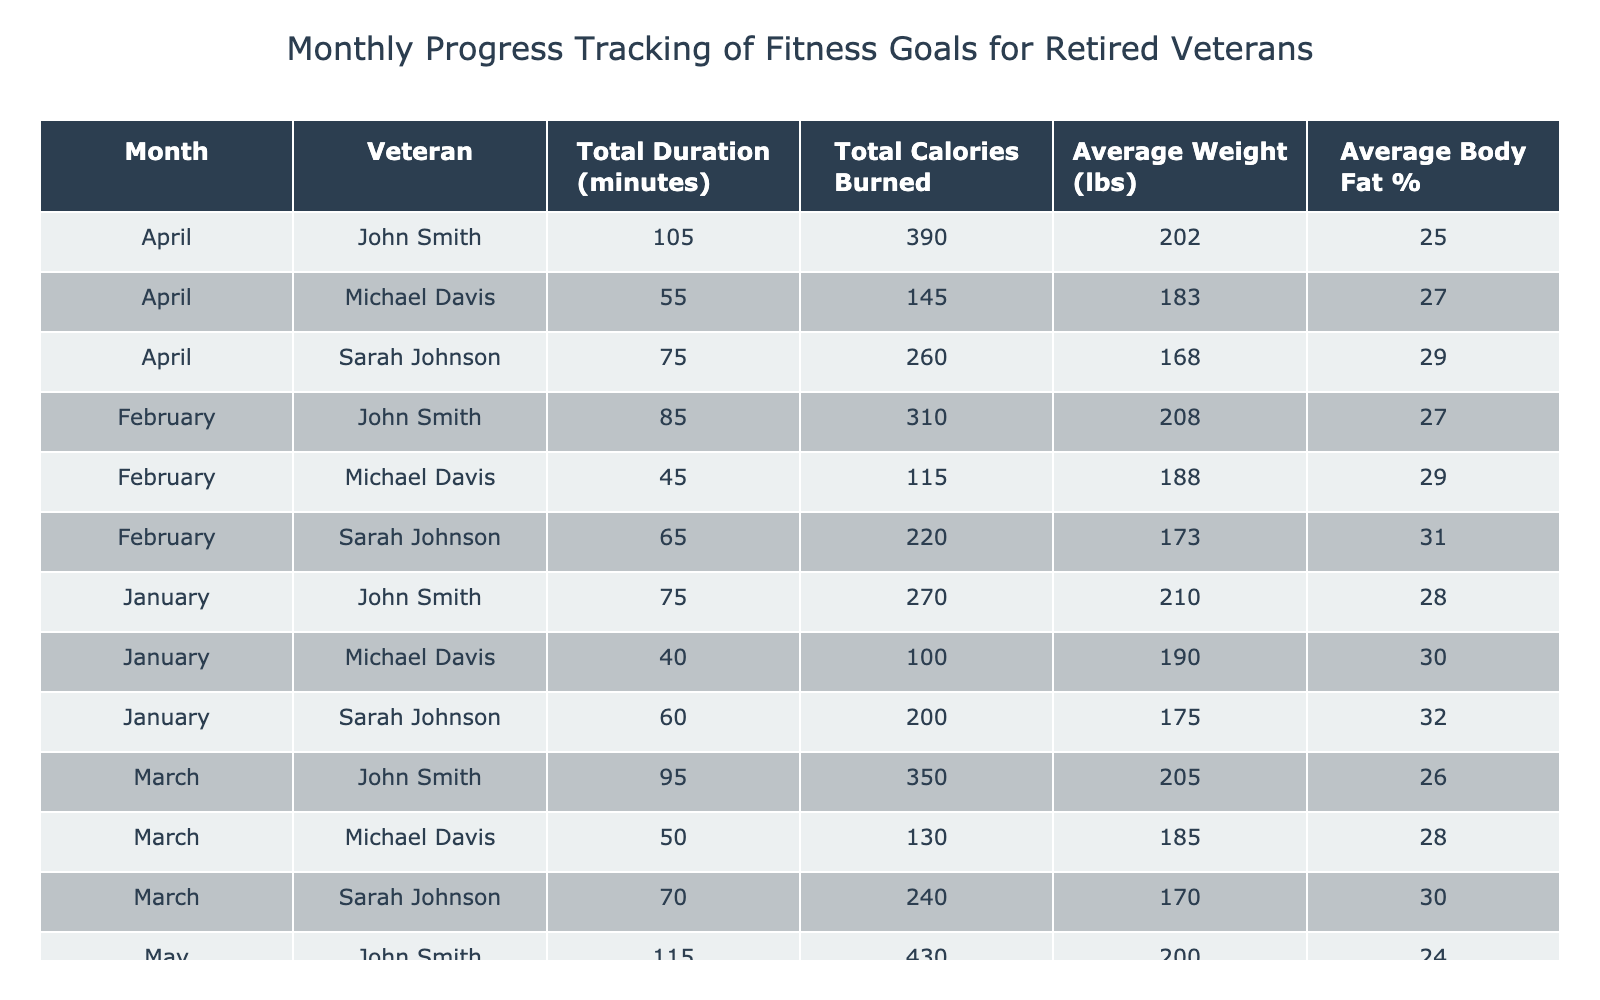What is the total duration of exercise for John Smith in February? In February, John Smith participated in Adaptive Yoga for 50 minutes and Seated Resistance Training for 35 minutes. Total duration = 50 + 35 = 85 minutes.
Answer: 85 minutes What is the average weight of Sarah Johnson across the months? Sarah Johnson's weight across the months is: January (175 lbs), February (173 lbs), March (170 lbs), and April (168 lbs). Averaging these: (175 + 173 + 170 + 168) / 4 = 171.5 lbs.
Answer: 171.5 lbs Did Michael Davis burn more calories in March compared to February? In March, Michael Davis burned 130 calories, while in February he burned 115 calories. Since 130 > 115, the answer is yes.
Answer: Yes What is the difference in total calories burned between John Smith in January and April? John Smith burned 150 calories in Adaptive Yoga and 120 in Seated Resistance Training in January, totaling 270 calories. In April, he burned 210 calories in Adaptive Yoga and 180 in Seated Resistance Training, totaling 390 calories. The difference is 390 - 270 = 120 calories.
Answer: 120 calories Which month had the highest average body fat percentage for John Smith? To find this, we look at John's body fat percentages for each month: January (28%), February (27%), March (26%), and April (25%). The highest is in January at 28%.
Answer: January What is the total duration of exercises conducted by Sarah Johnson in April? Sarah Johnson participated in Aqua Aerobics for 75 minutes in April. As there is only one entry for her that month, the total duration is simply 75 minutes.
Answer: 75 minutes Which veteran had the highest average calories burned across all months? Calculating the total calories burned for each veteran: John Smith (270+310+350+410=1,340, which averages to 335), Sarah Johnson (200+220+240+260=920, averaging to 230), and Michael Davis (100+115+130+145=490, averaging to 122.5). John Smith has the highest average.
Answer: John Smith Was there a month where Sarah Johnson participated in Aqua Aerobics for more than 70 minutes? She participated in Aqua Aerobics for 70 minutes in March and 75 minutes in April. Since 75 > 70, there are two months where she did exceed 70 minutes.
Answer: Yes What is the total average endurance level reported for all veterans in January? The endurance levels for January are: John Smith (4), Sarah Johnson (3), Michael Davis (2). The average is calculated as (4 + 3 + 2) / 3 = 3. Since there are three levels to average, the total average endurance level for January is 3.
Answer: 3 